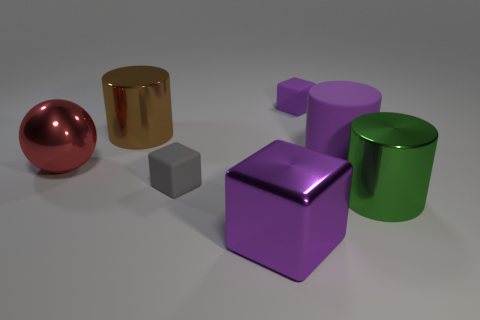What number of other things are there of the same color as the big cube?
Make the answer very short. 2. Are there more large spheres that are on the right side of the large purple metal object than spheres?
Provide a succinct answer. No. Are there any large green objects of the same shape as the red metal object?
Ensure brevity in your answer.  No. Are the gray object and the big purple object behind the large red metallic object made of the same material?
Provide a short and direct response. Yes. What is the color of the big sphere?
Your answer should be compact. Red. There is a big purple object that is to the left of the tiny thing that is behind the large brown shiny cylinder; what number of gray rubber cubes are behind it?
Your answer should be very brief. 1. There is a green cylinder; are there any brown shiny cylinders behind it?
Give a very brief answer. Yes. What number of red things are made of the same material as the large green object?
Your answer should be very brief. 1. How many objects are gray metallic cylinders or rubber objects?
Ensure brevity in your answer.  3. Is there a large purple rubber block?
Provide a short and direct response. No. 